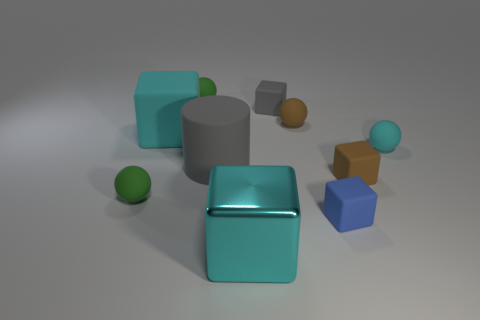Subtract all brown blocks. How many blocks are left? 4 Subtract all big cyan metal blocks. How many blocks are left? 4 Subtract all purple blocks. Subtract all purple balls. How many blocks are left? 5 Subtract all cylinders. How many objects are left? 9 Add 2 cyan blocks. How many cyan blocks exist? 4 Subtract 0 red blocks. How many objects are left? 10 Subtract all green blocks. Subtract all rubber things. How many objects are left? 1 Add 9 gray matte blocks. How many gray matte blocks are left? 10 